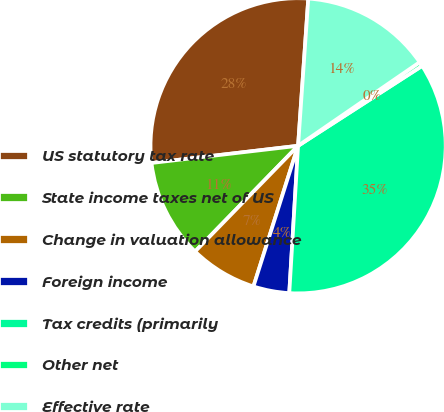<chart> <loc_0><loc_0><loc_500><loc_500><pie_chart><fcel>US statutory tax rate<fcel>State income taxes net of US<fcel>Change in valuation allowance<fcel>Foreign income<fcel>Tax credits (primarily<fcel>Other net<fcel>Effective rate<nl><fcel>27.96%<fcel>10.85%<fcel>7.4%<fcel>3.94%<fcel>35.06%<fcel>0.48%<fcel>14.31%<nl></chart> 